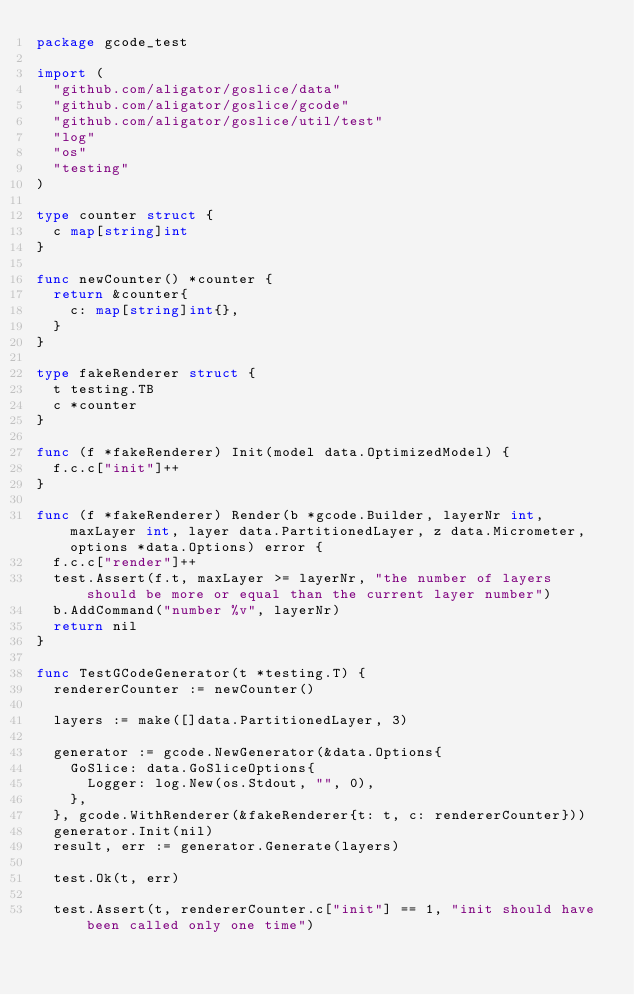Convert code to text. <code><loc_0><loc_0><loc_500><loc_500><_Go_>package gcode_test

import (
	"github.com/aligator/goslice/data"
	"github.com/aligator/goslice/gcode"
	"github.com/aligator/goslice/util/test"
	"log"
	"os"
	"testing"
)

type counter struct {
	c map[string]int
}

func newCounter() *counter {
	return &counter{
		c: map[string]int{},
	}
}

type fakeRenderer struct {
	t testing.TB
	c *counter
}

func (f *fakeRenderer) Init(model data.OptimizedModel) {
	f.c.c["init"]++
}

func (f *fakeRenderer) Render(b *gcode.Builder, layerNr int, maxLayer int, layer data.PartitionedLayer, z data.Micrometer, options *data.Options) error {
	f.c.c["render"]++
	test.Assert(f.t, maxLayer >= layerNr, "the number of layers should be more or equal than the current layer number")
	b.AddCommand("number %v", layerNr)
	return nil
}

func TestGCodeGenerator(t *testing.T) {
	rendererCounter := newCounter()

	layers := make([]data.PartitionedLayer, 3)

	generator := gcode.NewGenerator(&data.Options{
		GoSlice: data.GoSliceOptions{
			Logger: log.New(os.Stdout, "", 0),
		},
	}, gcode.WithRenderer(&fakeRenderer{t: t, c: rendererCounter}))
	generator.Init(nil)
	result, err := generator.Generate(layers)

	test.Ok(t, err)

	test.Assert(t, rendererCounter.c["init"] == 1, "init should have been called only one time")</code> 